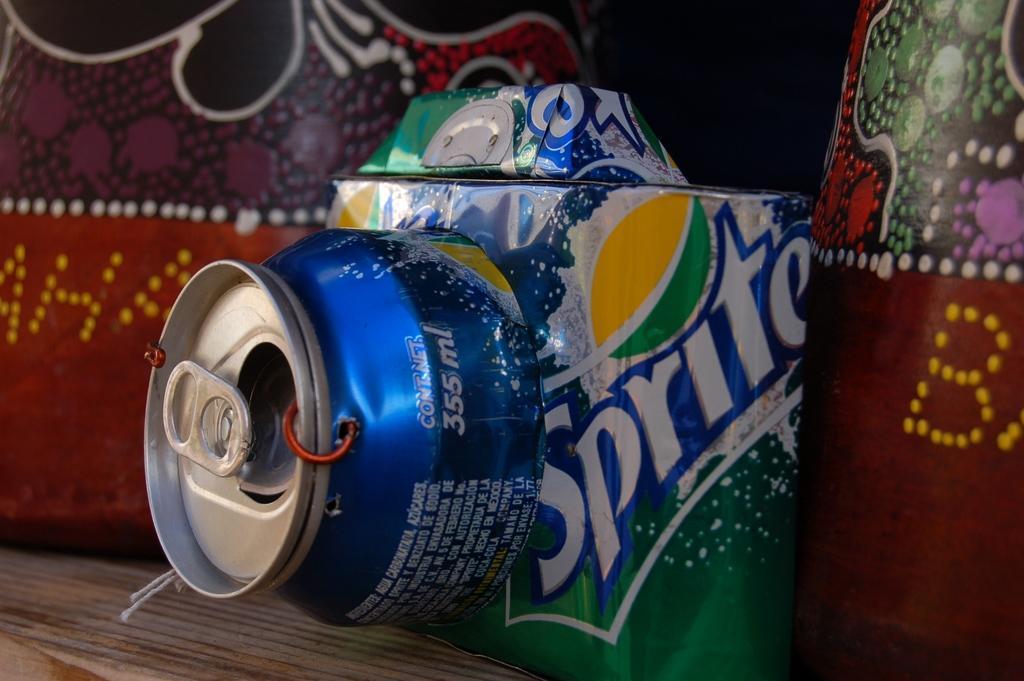Describe this image in one or two sentences. In this picture, I can see a sprite can with some painting on the wall. 